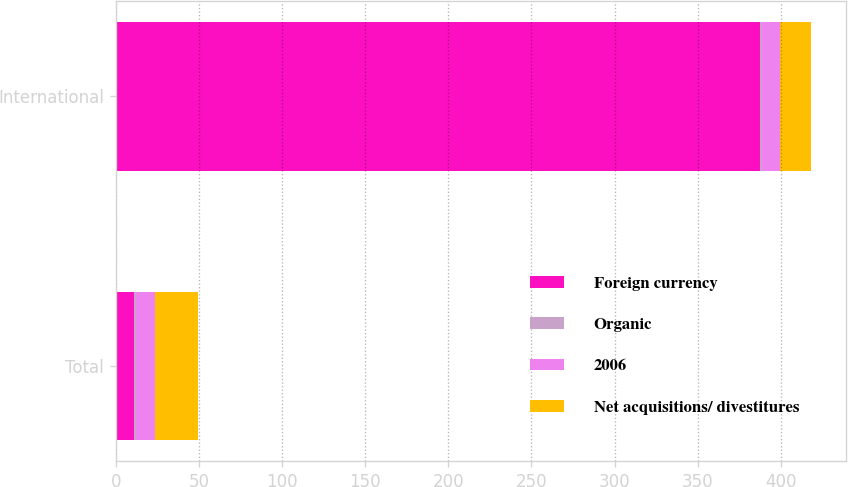Convert chart. <chart><loc_0><loc_0><loc_500><loc_500><stacked_bar_chart><ecel><fcel>Total<fcel>International<nl><fcel>Foreign currency<fcel>11.2<fcel>387.7<nl><fcel>Organic<fcel>0.9<fcel>0.9<nl><fcel>2006<fcel>11.2<fcel>10.7<nl><fcel>Net acquisitions/ divestitures<fcel>26.3<fcel>18.9<nl></chart> 